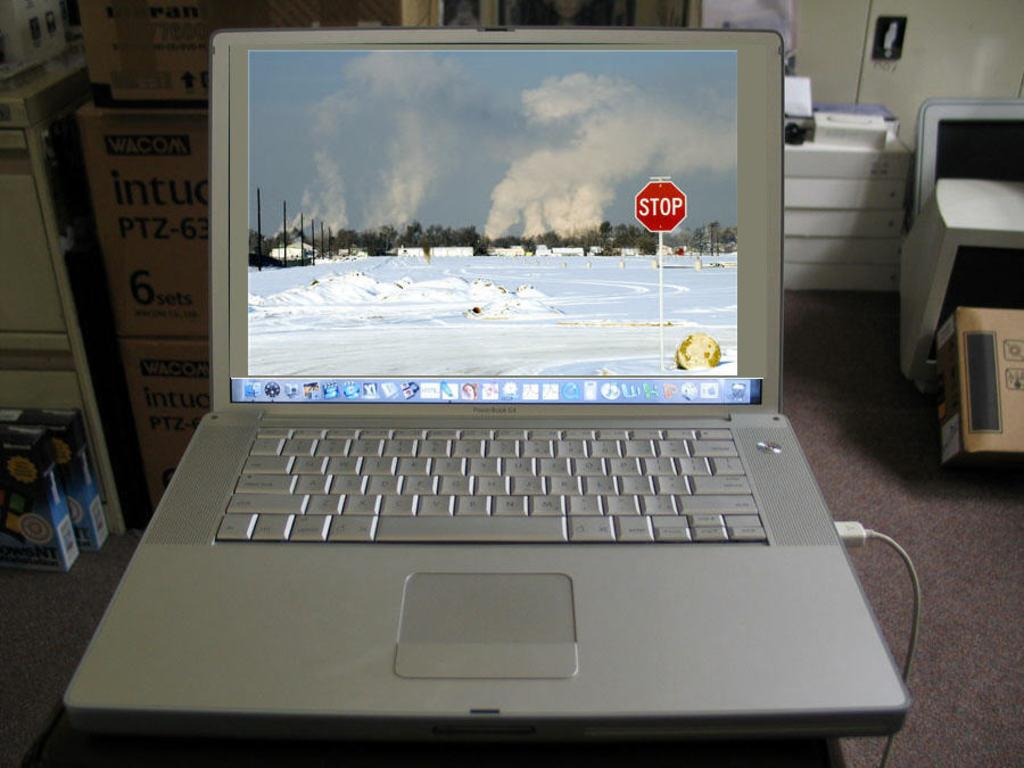<image>
Write a terse but informative summary of the picture. A laptop on a desk, the laptop is showing a full screen photo of a showy street and a red stop sign. 